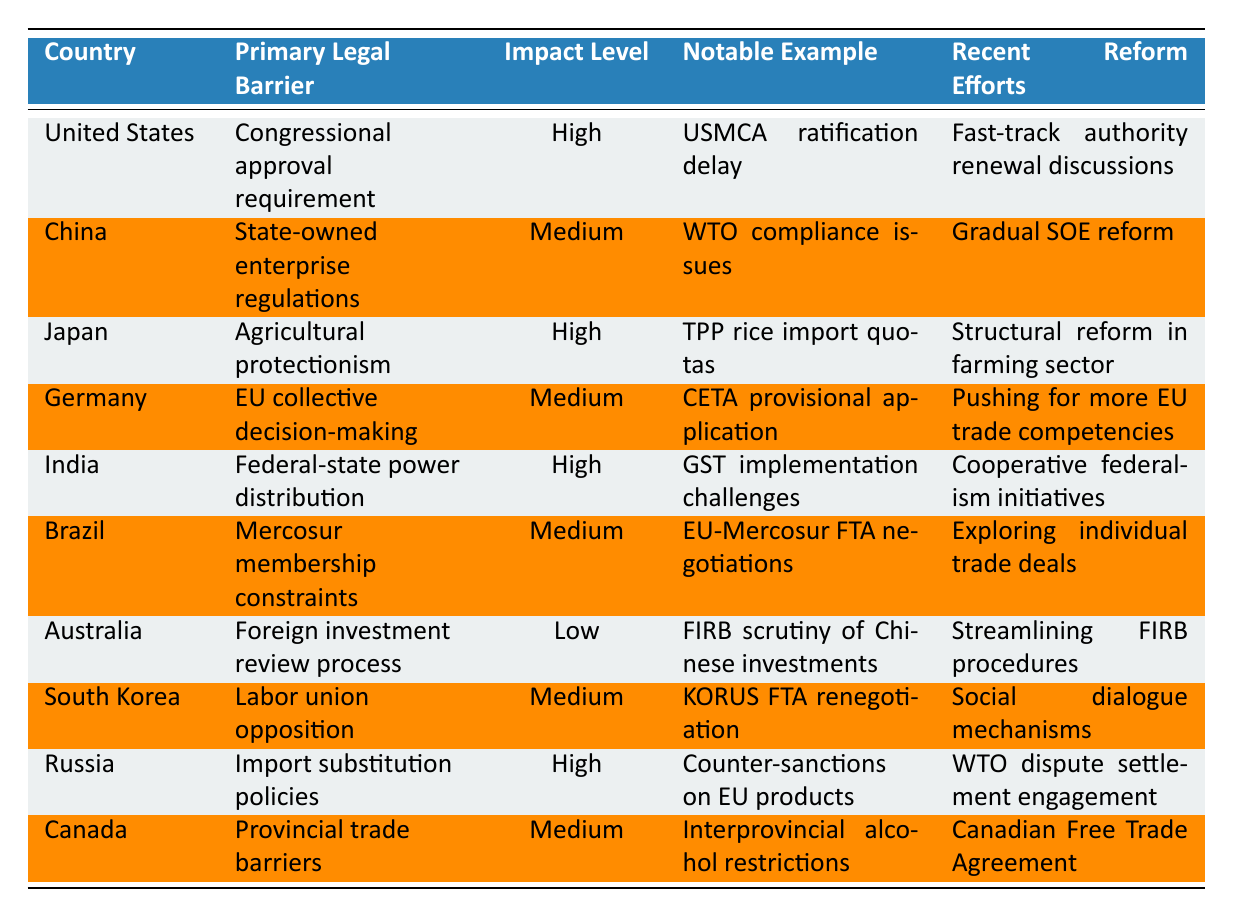What is the primary legal barrier for Canada in adopting international trade agreements? The table shows that the primary legal barrier for Canada is "Provincial trade barriers."
Answer: Provincial trade barriers Which country has a high impact level due to agricultural protectionism? The table indicates that Japan faces a high impact level due to "Agricultural protectionism."
Answer: Japan How many countries have a high impact level in the table? The table lists three countries—United States, Japan, and India—that are marked with a high impact level on their legal barriers.
Answer: Three Are there any countries with low impact levels for their legal barriers? The table reveals that Australia has a low impact level related to "Foreign investment review process."
Answer: Yes Which country experiences notable issues with state-owned enterprise regulations? According to the table, China is noted for facing issues related to "State-owned enterprise regulations."
Answer: China What is the notable example for the United States related to its primary legal barrier? The notable example for the United States is the "USMCA ratification delay," highlighting the consequences of its congressional approval requirement.
Answer: USMCA ratification delay Which two countries have a medium impact level and are exploring reform efforts? The table shows that Brazil and South Korea both have a medium impact level, with Brazil exploring "individual trade deals" and South Korea engaging in "social dialogue mechanisms."
Answer: Brazil and South Korea What recent reform effort is being pursued in India to address its legal barriers? The table states that India is pursuing "Cooperative federalism initiatives" as a recent reform effort to mitigate the effects of its federal-state power distribution barrier.
Answer: Cooperative federalism initiatives In total, how many countries are impacted by import substitution policies? The table indicates that only one country, Russia, is associated with "Import substitution policies" having a high impact level.
Answer: One What is the primary legal barrier for Germany related to international trade agreements? The table indicates that Germany's primary legal barrier is "EU collective decision-making."
Answer: EU collective decision-making 